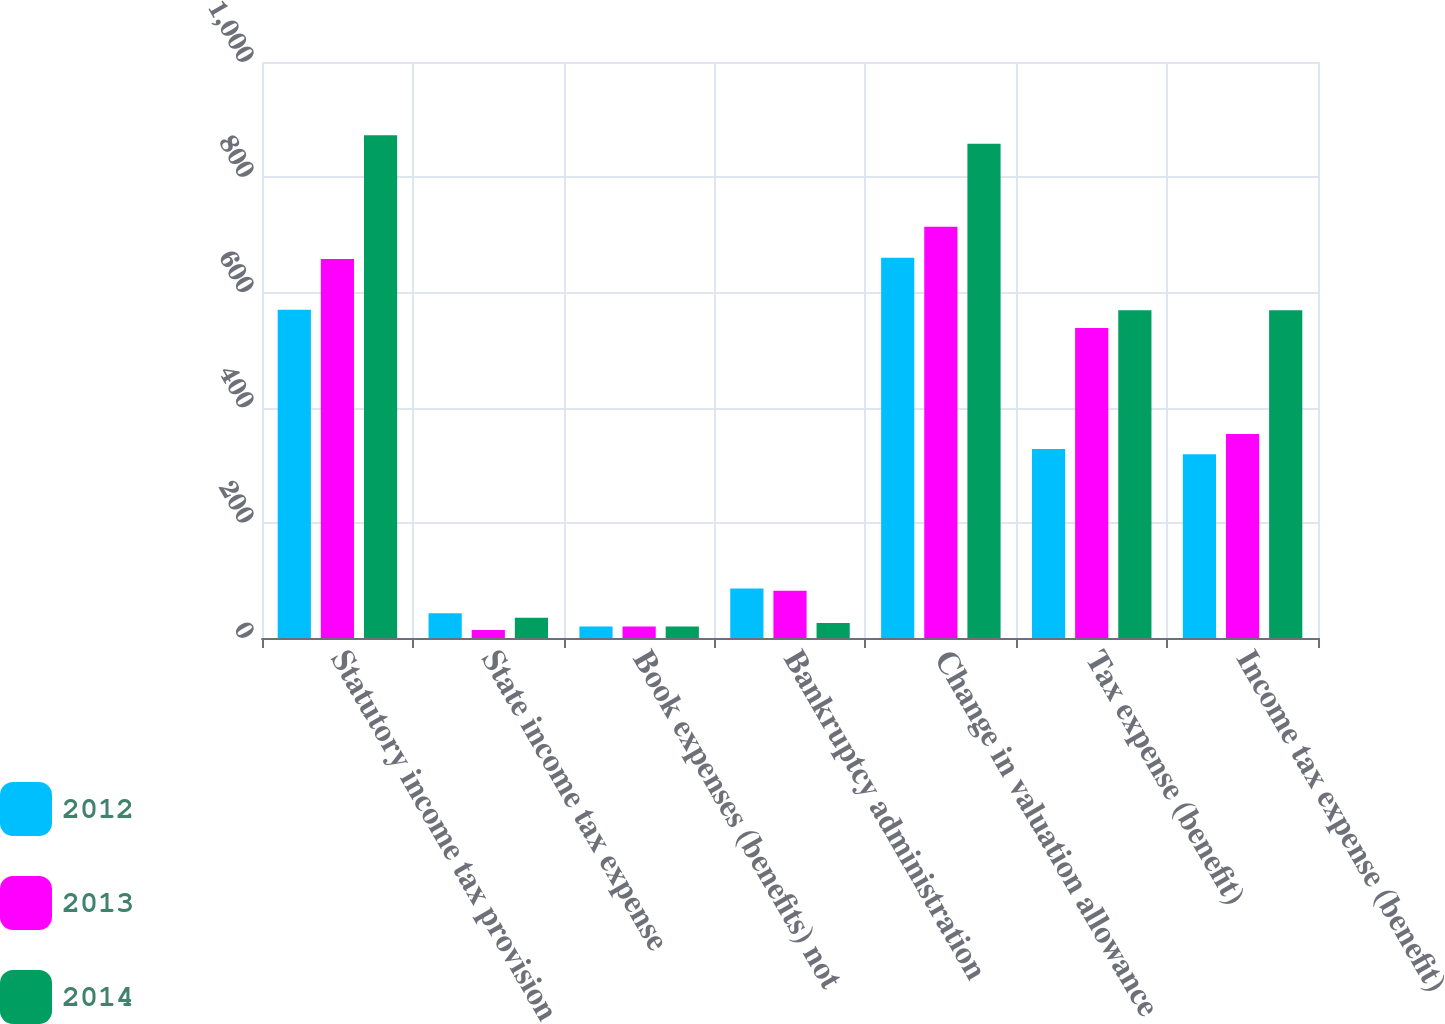Convert chart. <chart><loc_0><loc_0><loc_500><loc_500><stacked_bar_chart><ecel><fcel>Statutory income tax provision<fcel>State income tax expense<fcel>Book expenses (benefits) not<fcel>Bankruptcy administration<fcel>Change in valuation allowance<fcel>Tax expense (benefit)<fcel>Income tax expense (benefit)<nl><fcel>2012<fcel>570<fcel>43<fcel>20<fcel>86<fcel>660<fcel>328<fcel>319<nl><fcel>2013<fcel>658<fcel>14<fcel>20<fcel>82<fcel>714<fcel>538<fcel>354<nl><fcel>2014<fcel>873<fcel>35<fcel>20<fcel>26<fcel>858<fcel>569<fcel>569<nl></chart> 